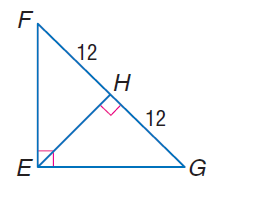Question: Find the measure of the altitude drawn to the hypotenuse.
Choices:
A. 6
B. 12
C. 16
D. 24
Answer with the letter. Answer: B 